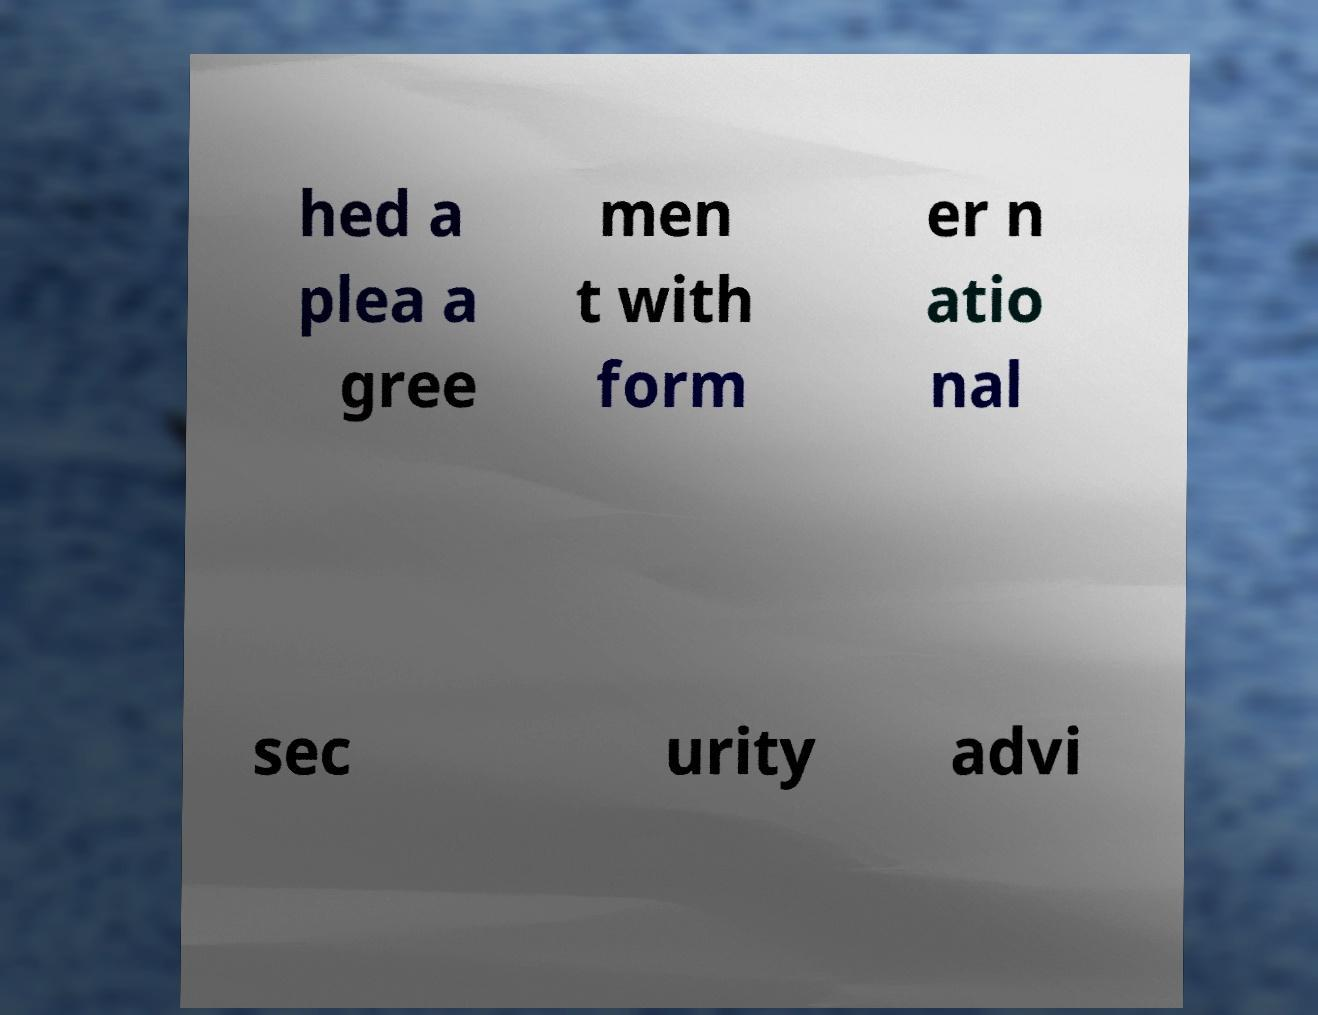Could you assist in decoding the text presented in this image and type it out clearly? hed a plea a gree men t with form er n atio nal sec urity advi 